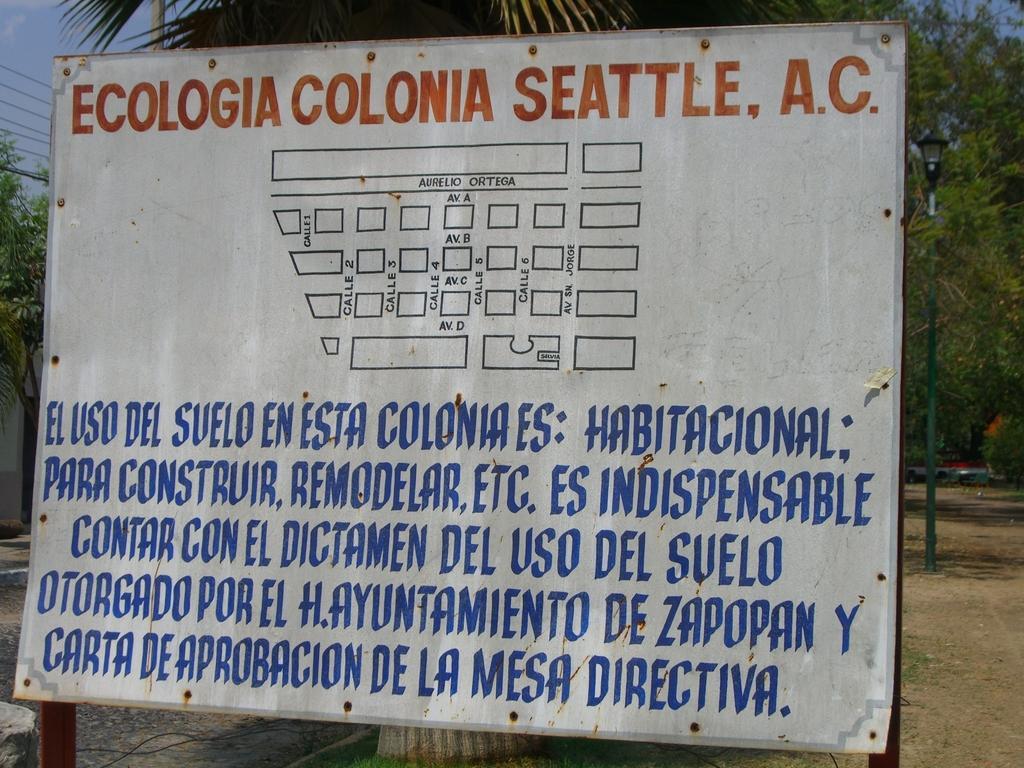Please provide a concise description of this image. In the foreground of the picture there is a board, on the board we can see map and text, behind the boat there is grass and tree. On the right there are trees, plant, pole and land. On the left there are trees, road, cables and sky. 